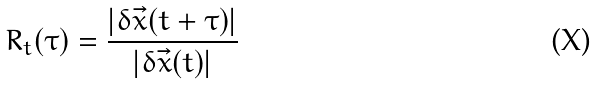<formula> <loc_0><loc_0><loc_500><loc_500>R _ { t } ( \tau ) = \frac { | \delta \vec { x } ( t + \tau ) | } { | \delta \vec { x } ( t ) | }</formula> 